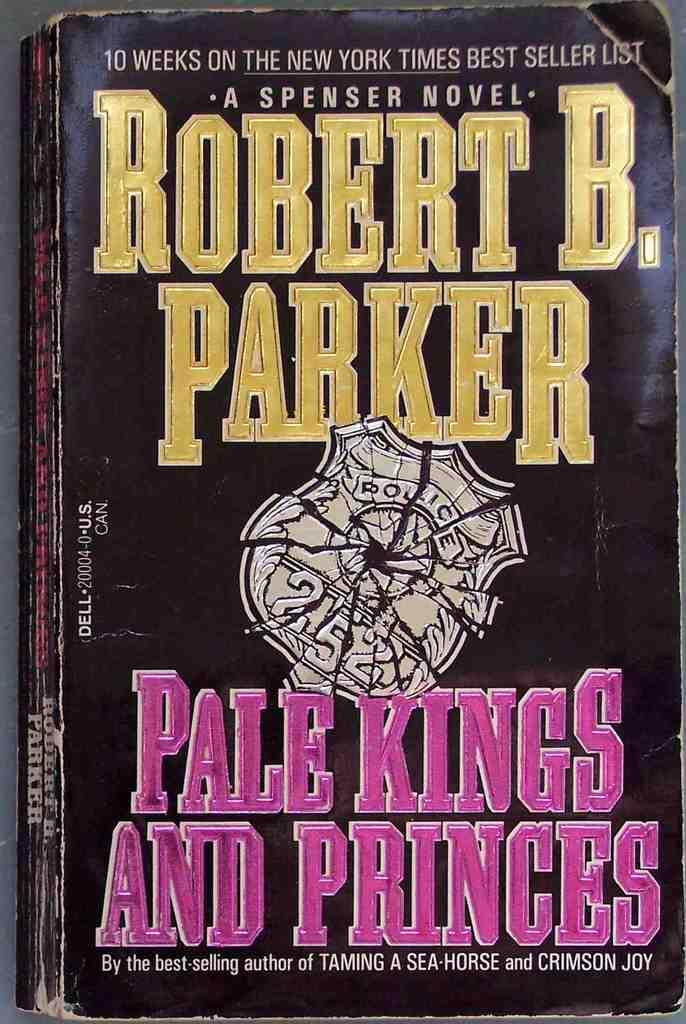<image>
Provide a brief description of the given image. A black book titled Pale Kings and Princes. 